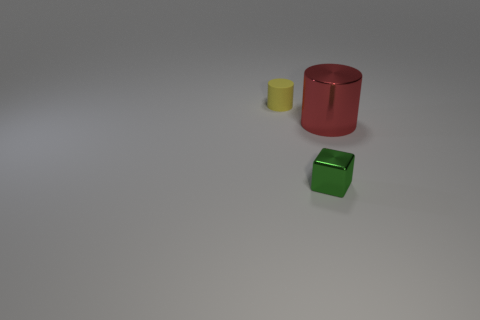Can you tell me about the colors and textures of the objects? Certainly! There are three objects that display vivid colors and different textures. The red cylinder has a smooth, metallic sheen, suggesting it might be made of metal. The yellow cylinder looks matte, possibly made of plastic. Lastly, the green cube also has a matte finish and a solid, opaque appearance. These objects offer a contrast not only in color but also in the material properties suggested by their textures. 